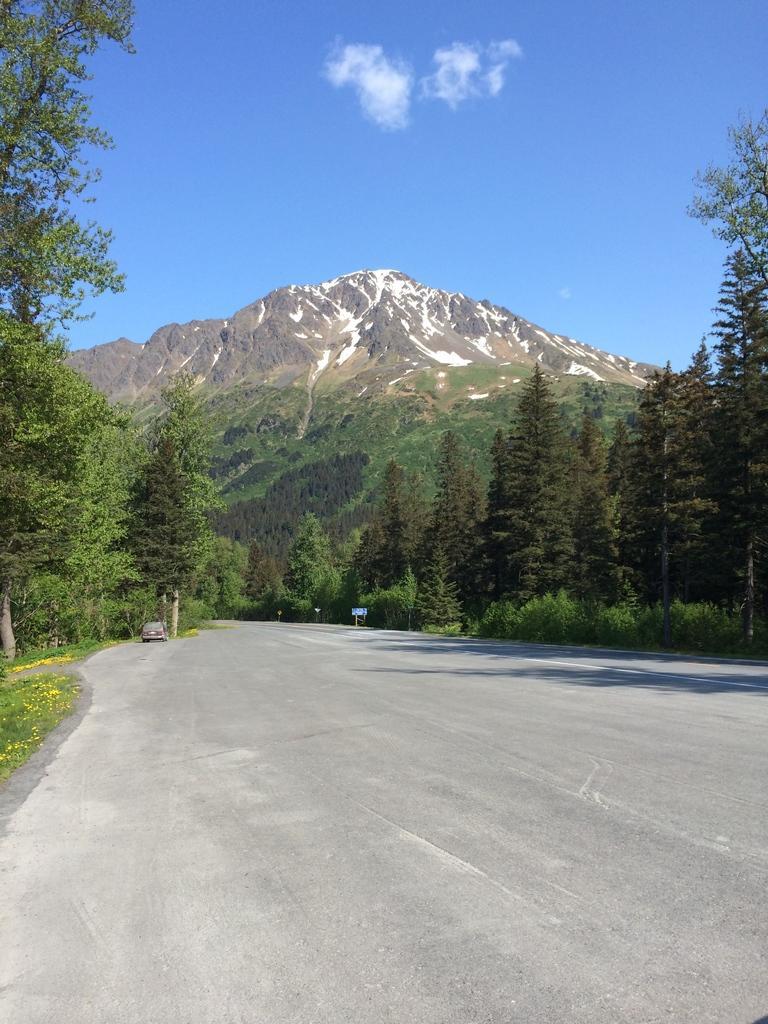Can you describe this image briefly? In the image we can see trees, mountain and the sky. Here we can see a vehicle on the road and the grass. 